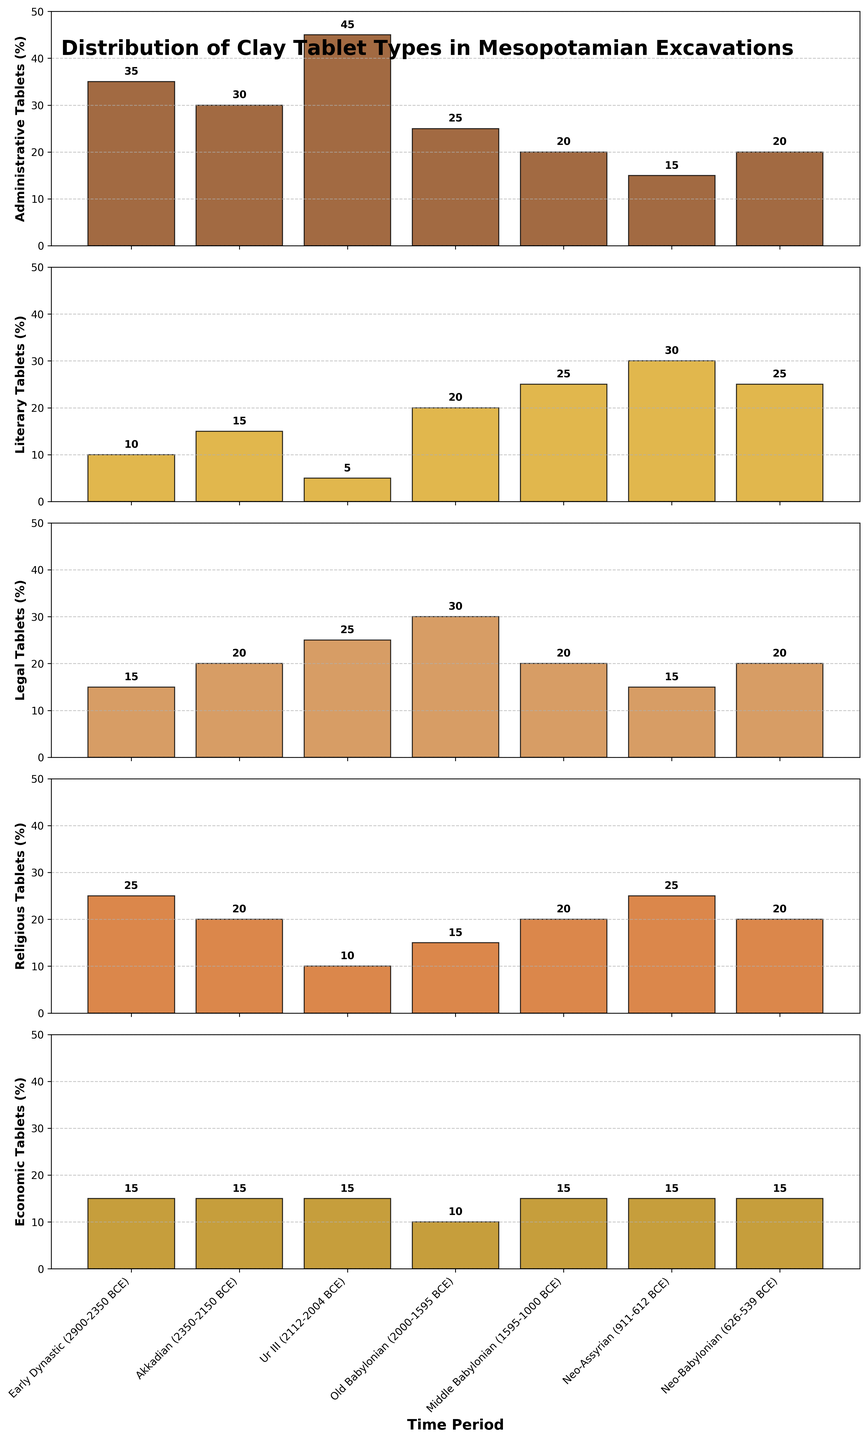What is the title of the figure? The title of the figure is placed at the top and usually describes what the figure is about.
Answer: Distribution of Clay Tablet Types in Mesopotamian Excavations How many time periods are represented in the figure? By counting the tick marks on the x-axis, each label represents a time period.
Answer: 7 Which time period has the highest number of administrative tablets? Look at the height of the bars in the 'Administrative Tablets' subplot. The tallest bar represents the highest number.
Answer: Ur III (2112-2004 BCE) During which period did literary tablets have their peak? Examine the 'Literary Tablets' subplot and identify the highest bar.
Answer: Neo-Assyrian (911-612 BCE) How many legal tablets were found in the Old Babylonian period? Locate the corresponding bar in the 'Legal Tablets' subplot and read the value annotated on top.
Answer: 30 Compare the number of religious tablets found in the Early Dynastic and Neo-Assyrian periods. Which period has more? Look at the 'Religious Tablets' subplot, compare the bar heights for both periods, and read the values.
Answer: Neo-Assyrian (911-612 BCE) What's the total number of economic tablets found across all periods? Sum the values of economic tablets from each time period: 15 + 15 + 15 + 10 + 15 + 15 + 15 = 100
Answer: 100 In which time period were the fewest administrative tablets found? Identify the shortest bar in the 'Administrative Tablets' subplot and read the label on the x-axis.
Answer: Neo-Assyrian (911-612 BCE) Which categories have an equal number of tablets in the Middle Babylonian period? Look for bars with the same height in the Middle Babylonian subplot, then verify that they have the same values.
Answer: Administrative, Legal, and Economic (20 each) What is the range of legal tablets found across all periods? Identify the maximum and minimum values in the 'Legal Tablets' subplot, then find the difference: Max (30) - Min (15) = 15
Answer: 15 